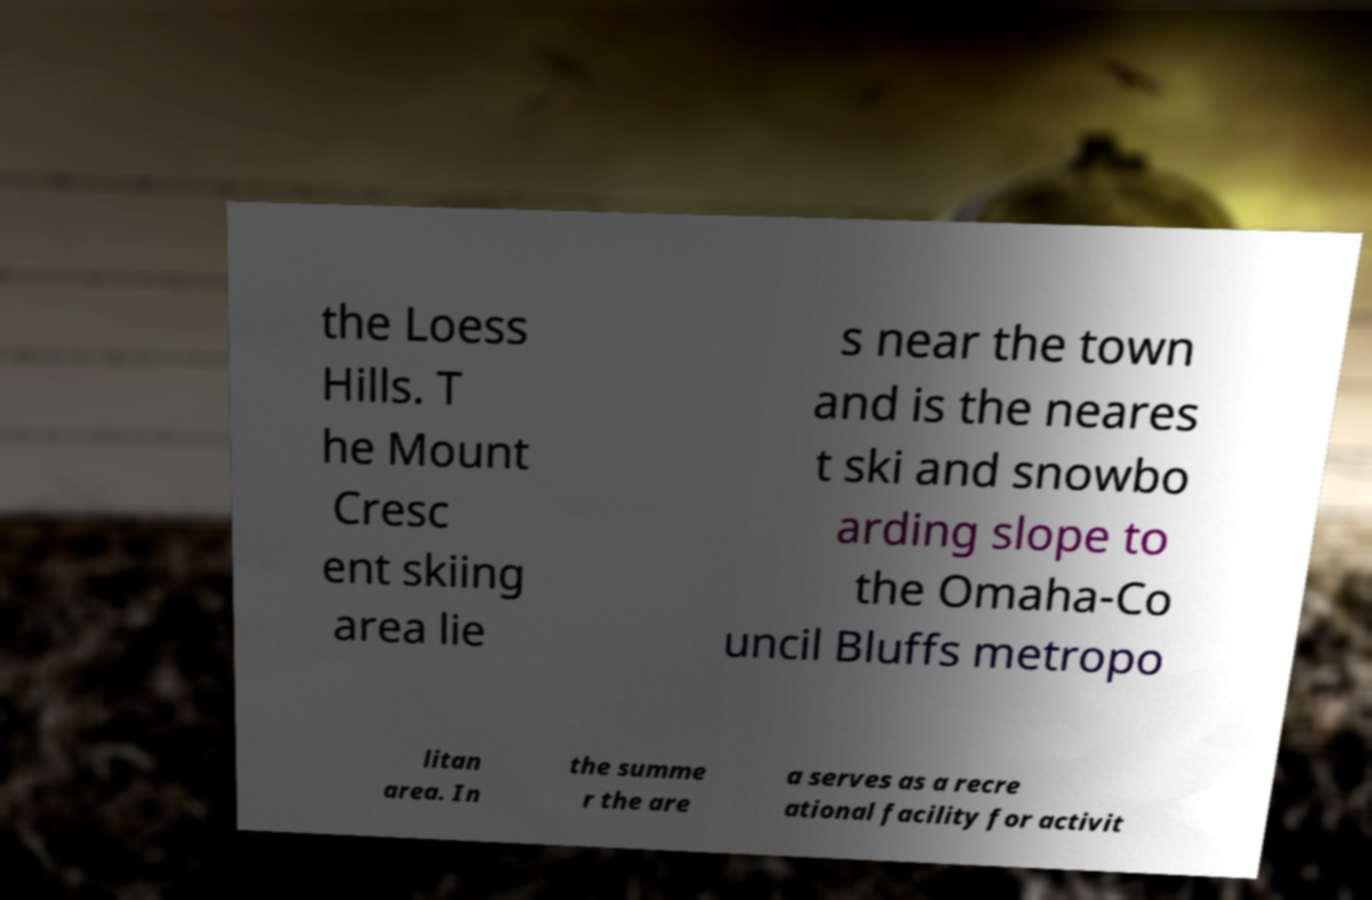I need the written content from this picture converted into text. Can you do that? the Loess Hills. T he Mount Cresc ent skiing area lie s near the town and is the neares t ski and snowbo arding slope to the Omaha-Co uncil Bluffs metropo litan area. In the summe r the are a serves as a recre ational facility for activit 